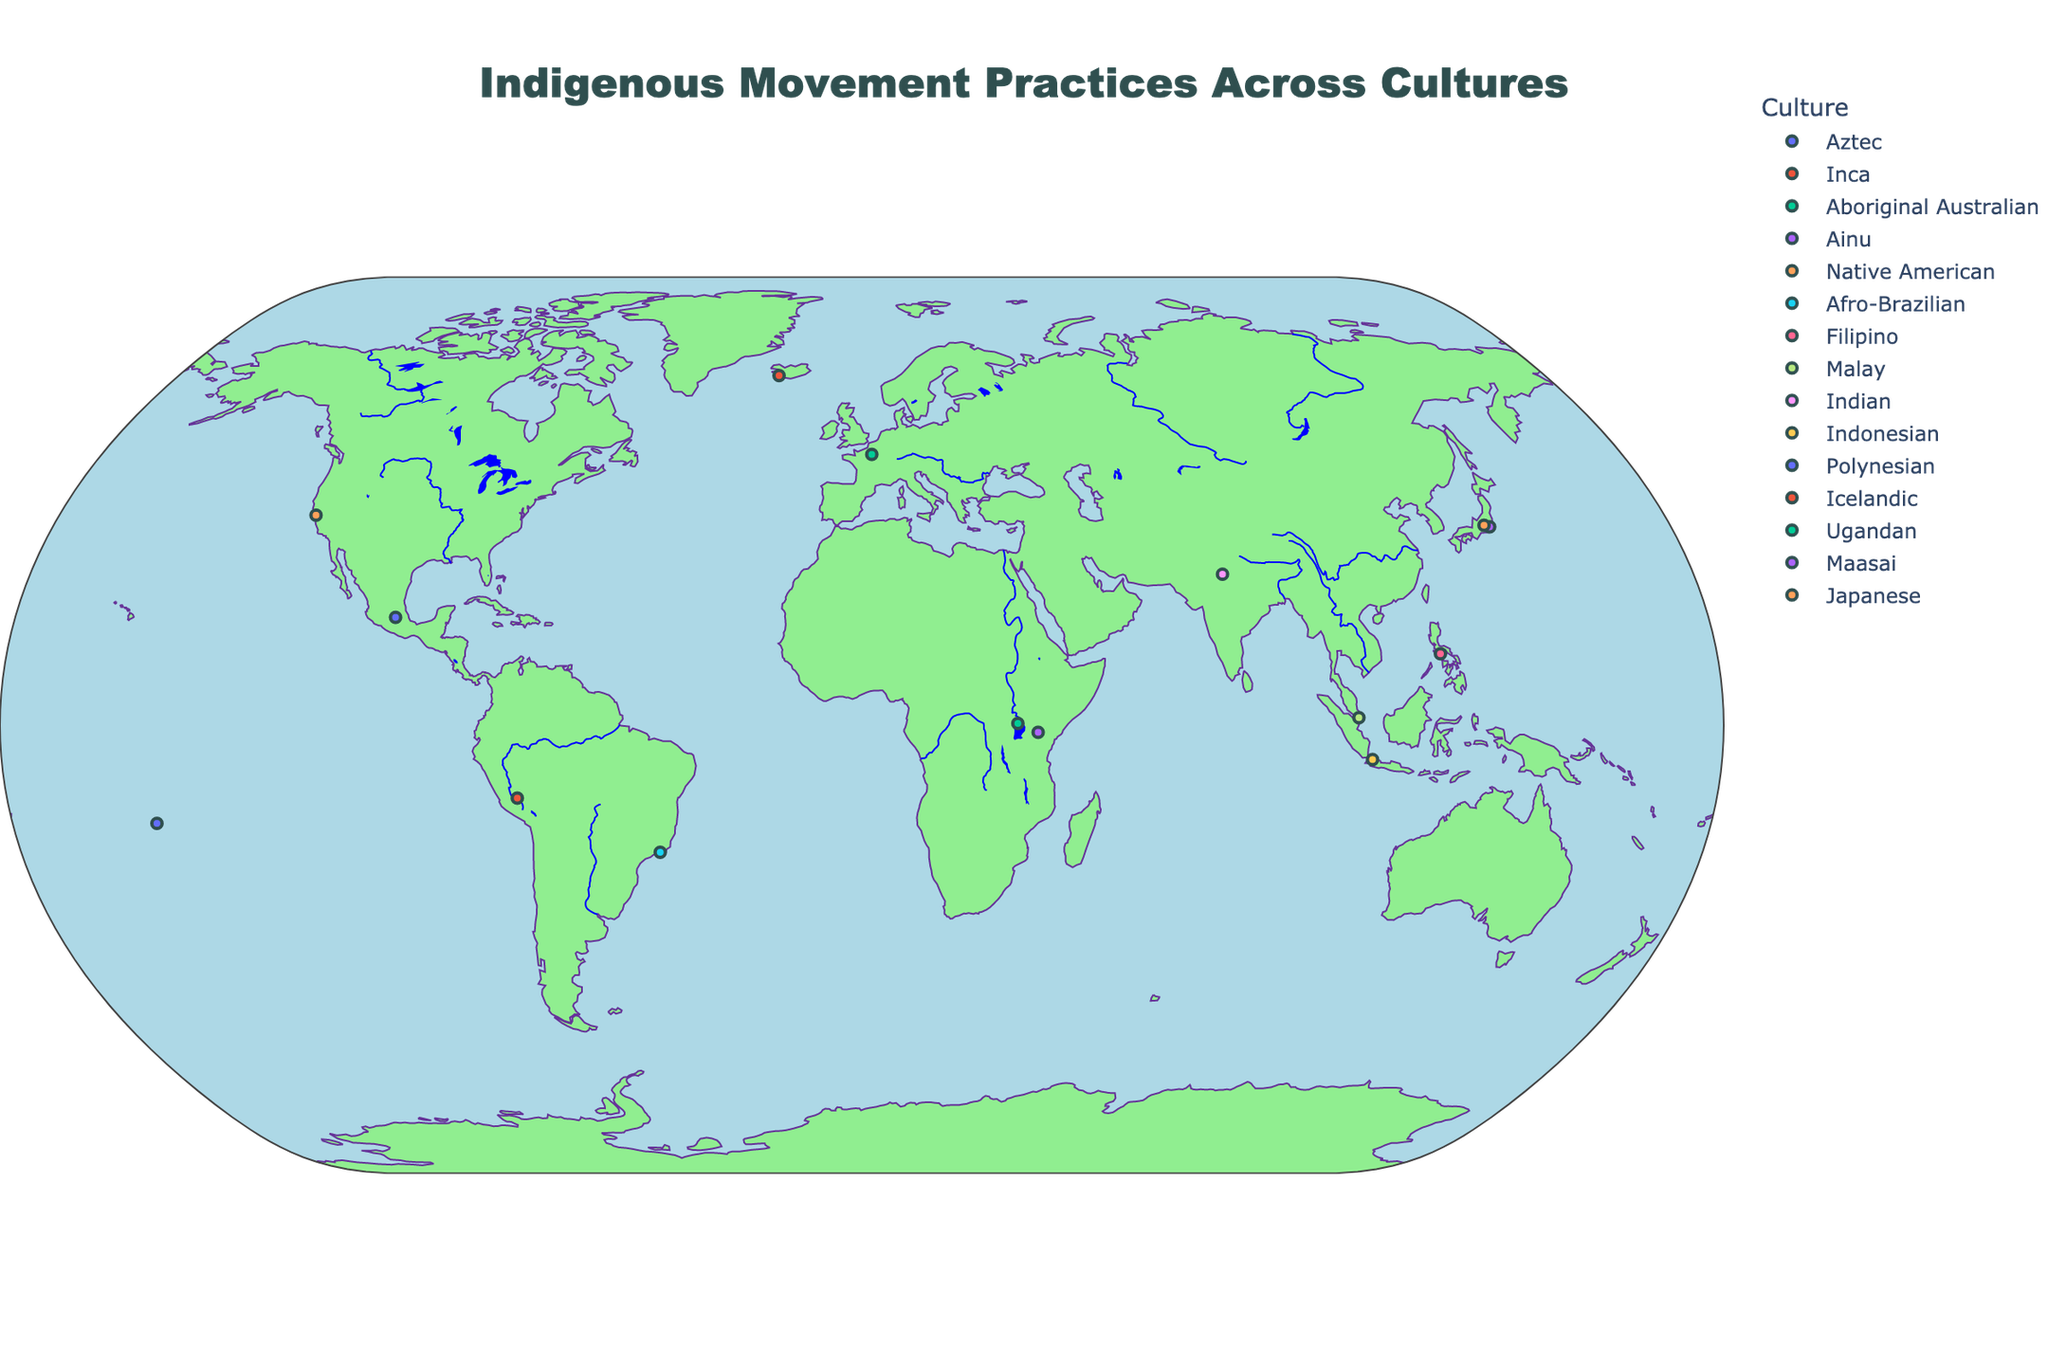what is the title of the map? The title can be found at the top center of the map. It is there to provide a summary of what the map is displaying. The title reads "Indigenous Movement Practices Across Cultures".
Answer: Indigenous Movement Practices Across Cultures how many data points are on this map? By counting the individual markers on the map, we can determine the number of data points. Each marker represents a different indigenous movement practice.
Answer: 14 which practice is located closest to the equator? The practice located closest to the equator will have a latitude closest to 0. By identifying and comparing latitudes, "Kizino" in Uganda appears to be the closest.
Answer: Kizino which culture's practice is shown in the country with the northernmost point? The northernmost point can be identified by finding the marker with the highest latitude value. In this case, Iceland (64.1265 latitude) is the northernmost, associated with the Icelandic culture.
Answer: Icelandic What process is performed by the Ainu culture? This can be identified by hovering over the marker located at the coordinates for the Ainu culture (35.6762, 139.6503 in Japan) and checking the hover text to see the practice name which is "Rimse".
Answer: Rimse which practices are located in Africa? To identify the African practices, we locate the markers within the African continent and then check the culture and practice names associated with these markers. The practices include "Kizino" by Ugandan culture and "Adumu" by Maasai culture.
Answer: Kizino and Adumu what is the significance of the Ghost Dance? Hovering over the marker at 37.7749,-122.4194 associated with Native American culture will provide the significance of the Ghost Dance, which is "Spiritual renewal and unity".
Answer: Spiritual renewal and unity compare the practices of the Aztec and Inca cultures in terms of their significance. The significance of each practice is given in the hover data. For the Aztec's Danza Azteca, it is "Ceremonial and spiritual expression". For the Inca's Taki Onqoy, it is "Resistance and cultural preservation".
Answer: Danza Azteca: Ceremonial and spiritual expression; Taki Onqoy: Resistance and cultural preservation which two practices are geographically closest to each other? To determine this, compare the distances between all pairs of Latitude and Longitude coordinates. The closest pairs are Danza Azteca (19.4326,-99.1332) and Taki Onqoy (-13.1631,-72.5450).
Answer: Danza Azteca and Taki Onqoy how many practices are there from Asian cultures? Asian practices can be identified by locating the markers within Asia and counting them. They include practices from Ainu, Filipino, Malay, Indian, Indonesian, and Japanese cultures.
Answer: 6 